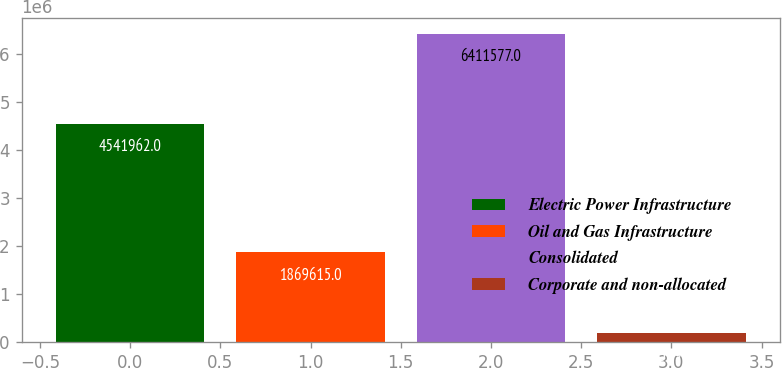Convert chart. <chart><loc_0><loc_0><loc_500><loc_500><bar_chart><fcel>Electric Power Infrastructure<fcel>Oil and Gas Infrastructure<fcel>Consolidated<fcel>Corporate and non-allocated<nl><fcel>4.54196e+06<fcel>1.86962e+06<fcel>6.41158e+06<fcel>185899<nl></chart> 